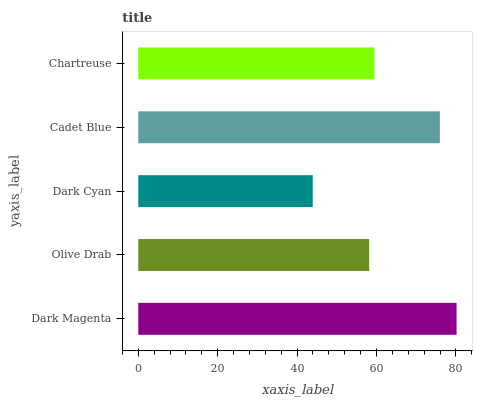Is Dark Cyan the minimum?
Answer yes or no. Yes. Is Dark Magenta the maximum?
Answer yes or no. Yes. Is Olive Drab the minimum?
Answer yes or no. No. Is Olive Drab the maximum?
Answer yes or no. No. Is Dark Magenta greater than Olive Drab?
Answer yes or no. Yes. Is Olive Drab less than Dark Magenta?
Answer yes or no. Yes. Is Olive Drab greater than Dark Magenta?
Answer yes or no. No. Is Dark Magenta less than Olive Drab?
Answer yes or no. No. Is Chartreuse the high median?
Answer yes or no. Yes. Is Chartreuse the low median?
Answer yes or no. Yes. Is Cadet Blue the high median?
Answer yes or no. No. Is Olive Drab the low median?
Answer yes or no. No. 